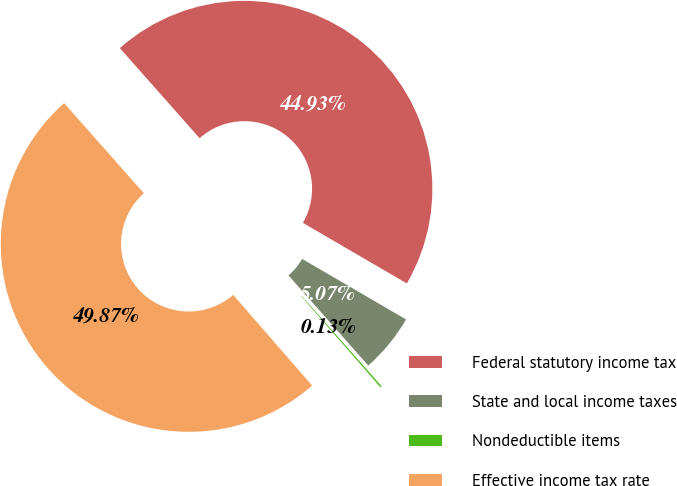Convert chart. <chart><loc_0><loc_0><loc_500><loc_500><pie_chart><fcel>Federal statutory income tax<fcel>State and local income taxes<fcel>Nondeductible items<fcel>Effective income tax rate<nl><fcel>44.93%<fcel>5.07%<fcel>0.13%<fcel>49.87%<nl></chart> 